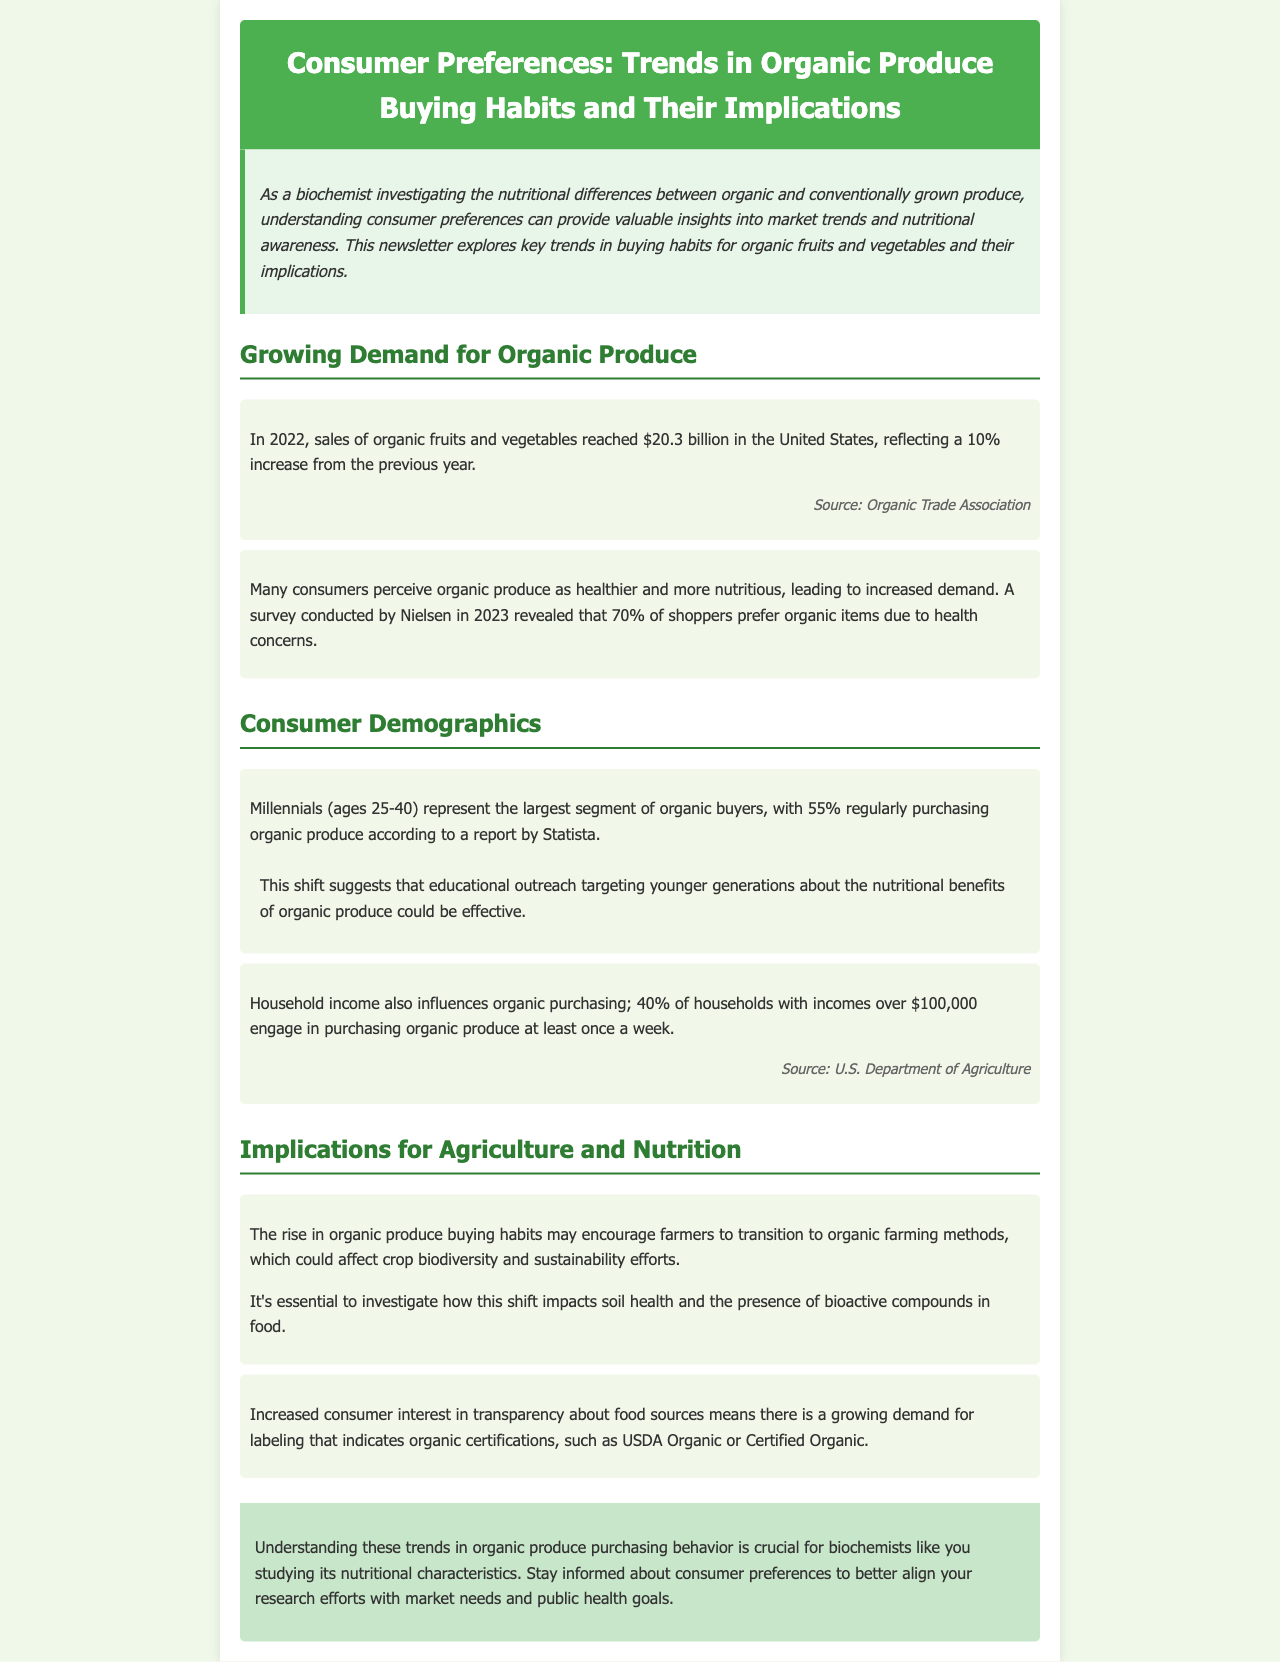What was the sales figure for organic fruits and vegetables in 2022? The document states that sales of organic fruits and vegetables reached $20.3 billion in 2022.
Answer: $20.3 billion What percentage of shoppers prefer organic items due to health concerns? According to a survey conducted by Nielsen in 2023, 70% of shoppers prefer organic items due to health concerns.
Answer: 70% Which age group represents the largest segment of organic buyers? The document mentions that Millennials (ages 25-40) represent the largest segment of organic buyers.
Answer: Millennials What percentage of households with incomes over $100,000 purchase organic produce weekly? The document indicates that 40% of households with incomes over $100,000 purchase organic produce at least once a week.
Answer: 40% What implication does the rise in organic produce buying habits suggest for farmers? The rise in organic produce buying habits may encourage farmers to transition to organic farming methods.
Answer: Transition to organic farming methods Why is it essential to investigate the impact of increased organic produce purchasing? The document notes it's essential to investigate how this shift impacts soil health and the presence of bioactive compounds in food.
Answer: Soil health and bioactive compounds What labeling is in high demand due to increased consumer interest? The document states there is growing demand for labeling that indicates organic certifications, such as USDA Organic or Certified Organic.
Answer: Organic certifications Which organization provided the sales statistic for organic vegetables and fruits? The source of the statistic for organic produce sales is the Organic Trade Association.
Answer: Organic Trade Association What overarching message does the conclusion convey to biochemists? The conclusion emphasizes the importance of staying informed about consumer preferences to align research with market needs and public health goals.
Answer: Align research with market needs 